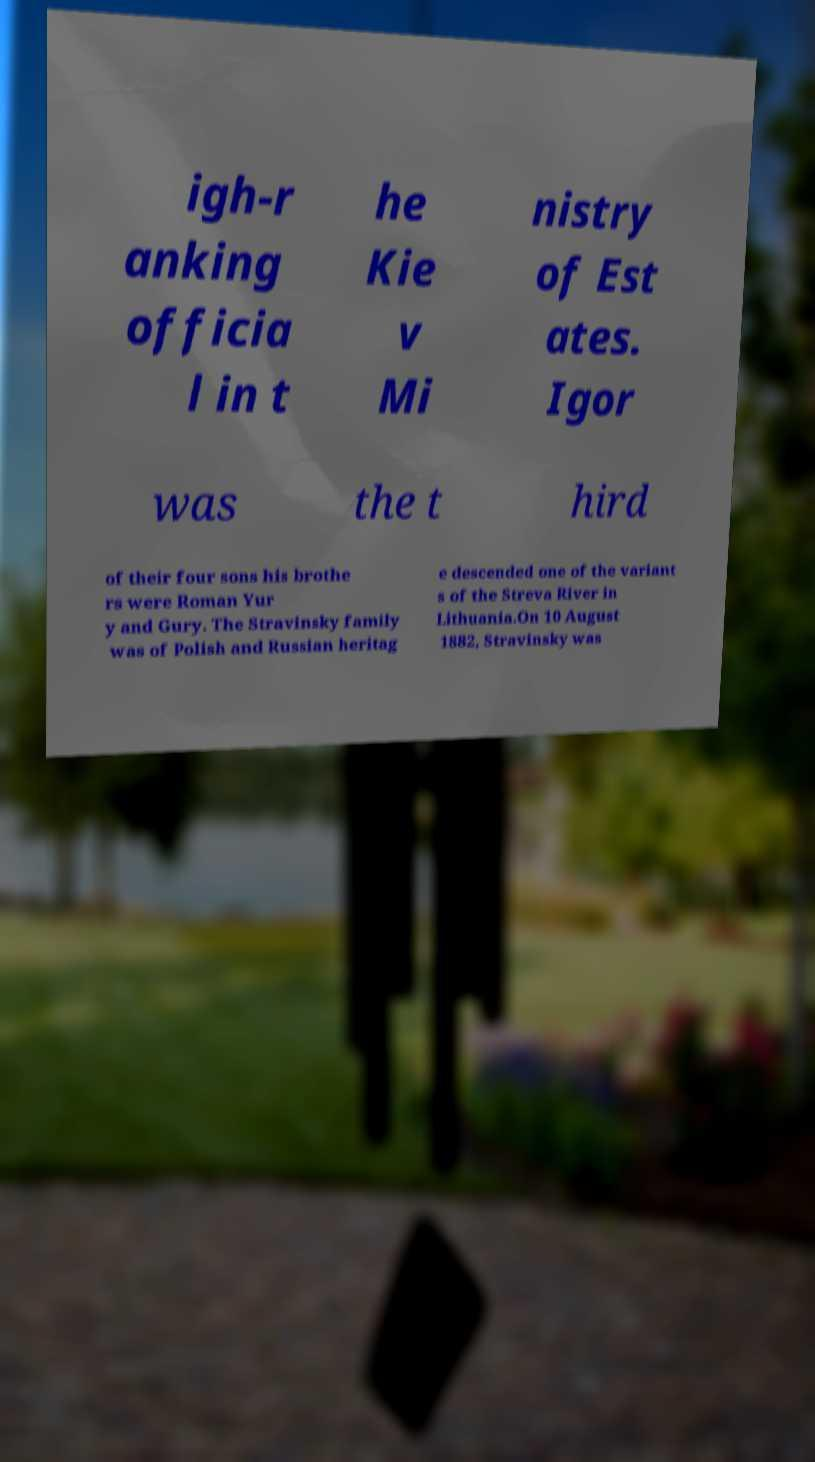For documentation purposes, I need the text within this image transcribed. Could you provide that? igh-r anking officia l in t he Kie v Mi nistry of Est ates. Igor was the t hird of their four sons his brothe rs were Roman Yur y and Gury. The Stravinsky family was of Polish and Russian heritag e descended one of the variant s of the Streva River in Lithuania.On 10 August 1882, Stravinsky was 